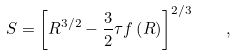<formula> <loc_0><loc_0><loc_500><loc_500>S = \left [ R ^ { 3 / 2 } - \frac { 3 } { 2 } \tau f \left ( R \right ) \right ] ^ { 2 / 3 } \quad ,</formula> 